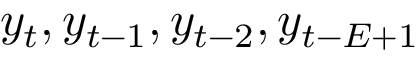Convert formula to latex. <formula><loc_0><loc_0><loc_500><loc_500>y _ { t } , y _ { t - 1 } , y _ { t - 2 } , y _ { t - E + 1 }</formula> 